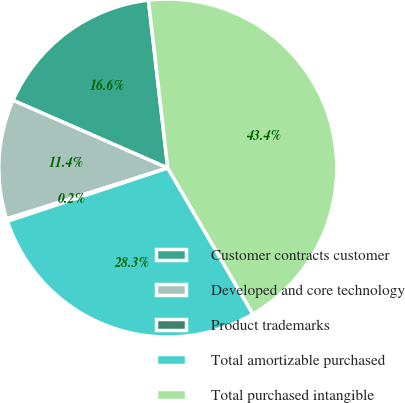Convert chart to OTSL. <chart><loc_0><loc_0><loc_500><loc_500><pie_chart><fcel>Customer contracts customer<fcel>Developed and core technology<fcel>Product trademarks<fcel>Total amortizable purchased<fcel>Total purchased intangible<nl><fcel>16.61%<fcel>11.43%<fcel>0.24%<fcel>28.29%<fcel>43.43%<nl></chart> 